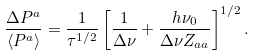Convert formula to latex. <formula><loc_0><loc_0><loc_500><loc_500>\frac { \Delta P ^ { a } } { \langle P ^ { a } \rangle } = \frac { 1 } { \tau ^ { 1 / 2 } } \left [ \frac { 1 } { \Delta \nu } + \frac { h \nu _ { 0 } } { \Delta \nu Z _ { a a } } \right ] ^ { 1 / 2 } .</formula> 